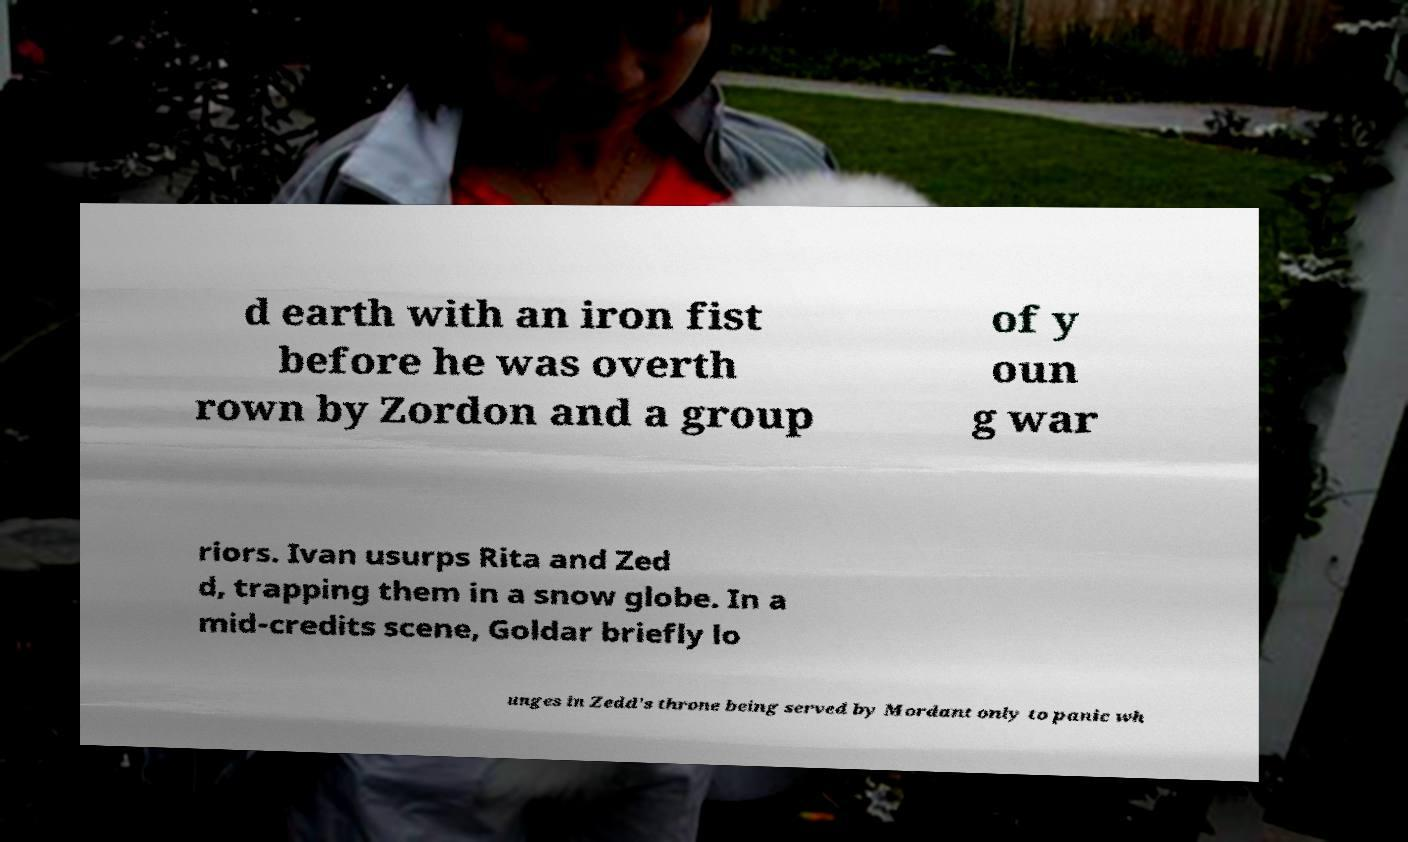Please identify and transcribe the text found in this image. d earth with an iron fist before he was overth rown by Zordon and a group of y oun g war riors. Ivan usurps Rita and Zed d, trapping them in a snow globe. In a mid-credits scene, Goldar briefly lo unges in Zedd's throne being served by Mordant only to panic wh 